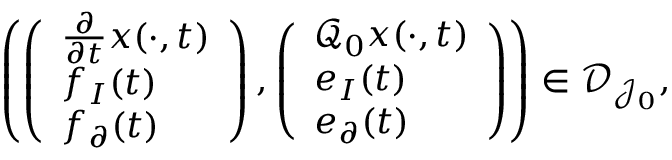Convert formula to latex. <formula><loc_0><loc_0><loc_500><loc_500>\begin{array} { r } { \left ( \left ( \begin{array} { l } { \frac { \partial } { \partial t } x ( \cdot , t ) } \\ { f _ { I } ( t ) } \\ { f _ { \partial } ( t ) } \end{array} \right ) , \left ( \begin{array} { l } { \mathcal { Q } _ { 0 } x ( \cdot , t ) } \\ { e _ { I } ( t ) } \\ { e _ { \partial } ( t ) } \end{array} \right ) \right ) \in \mathcal { D } _ { \mathcal { J } _ { 0 } } , } \end{array}</formula> 